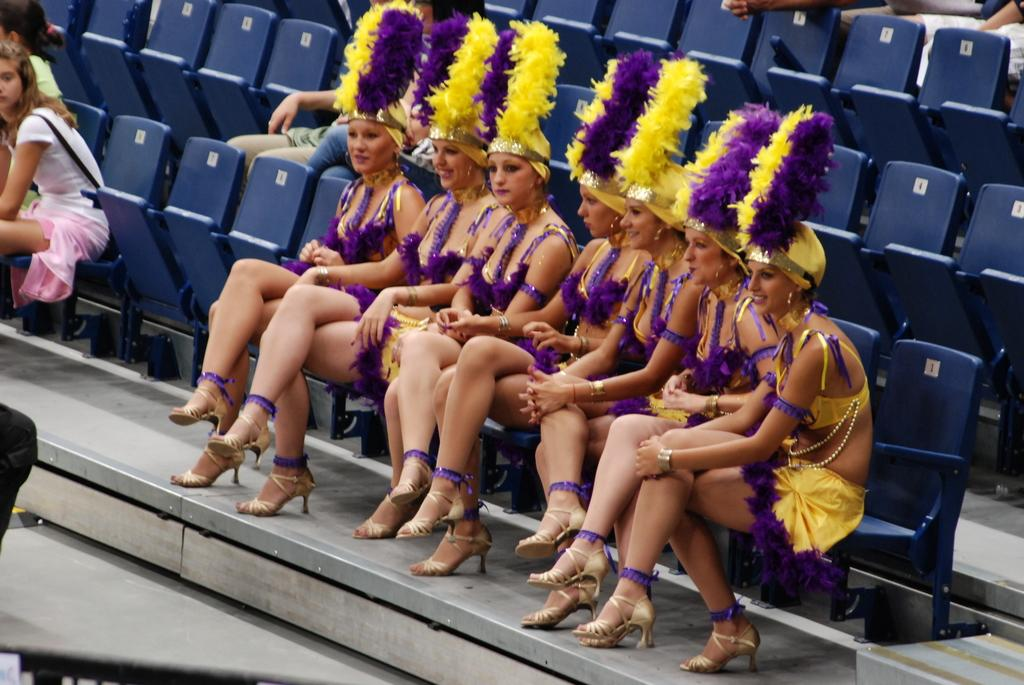Who is present in the image? There are women in the image. What are the women doing in the image? The women are sitting on chairs. What type of zebra can be seen in the image? There is no zebra present in the image. Can you point out the map in the image? There is no map present in the image. 